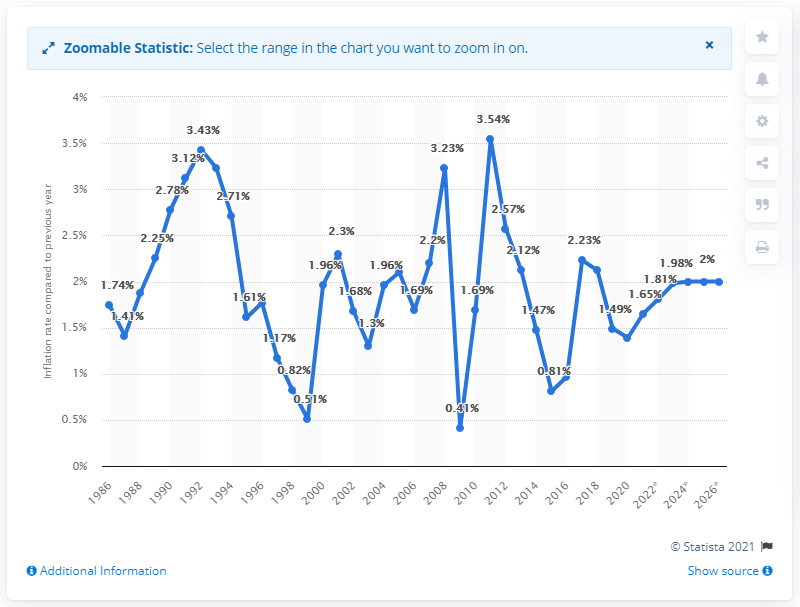List a handful of essential elements in this visual. In 2020, the inflation rate in Austria was 1.39%. 